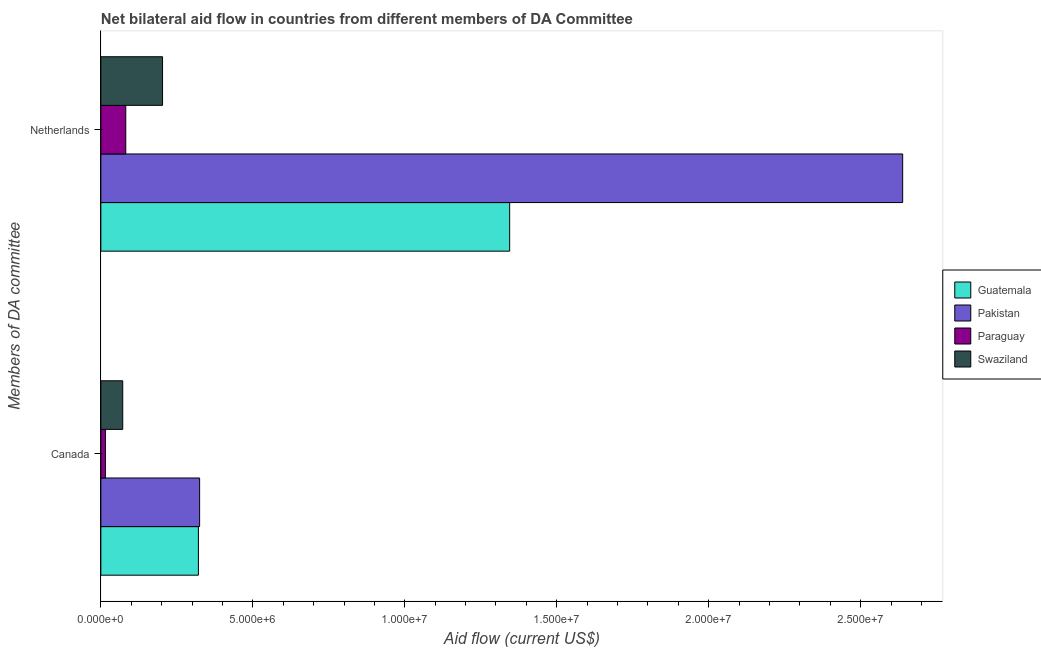How many groups of bars are there?
Provide a short and direct response. 2. Are the number of bars per tick equal to the number of legend labels?
Your answer should be very brief. Yes. Are the number of bars on each tick of the Y-axis equal?
Offer a very short reply. Yes. How many bars are there on the 2nd tick from the top?
Your response must be concise. 4. What is the label of the 2nd group of bars from the top?
Keep it short and to the point. Canada. What is the amount of aid given by canada in Pakistan?
Provide a succinct answer. 3.25e+06. Across all countries, what is the maximum amount of aid given by canada?
Provide a succinct answer. 3.25e+06. Across all countries, what is the minimum amount of aid given by netherlands?
Offer a very short reply. 8.20e+05. In which country was the amount of aid given by canada maximum?
Provide a short and direct response. Pakistan. In which country was the amount of aid given by netherlands minimum?
Keep it short and to the point. Paraguay. What is the total amount of aid given by canada in the graph?
Your response must be concise. 7.33e+06. What is the difference between the amount of aid given by canada in Pakistan and that in Swaziland?
Provide a succinct answer. 2.53e+06. What is the difference between the amount of aid given by netherlands in Pakistan and the amount of aid given by canada in Swaziland?
Provide a short and direct response. 2.57e+07. What is the average amount of aid given by canada per country?
Provide a succinct answer. 1.83e+06. What is the difference between the amount of aid given by canada and amount of aid given by netherlands in Swaziland?
Give a very brief answer. -1.31e+06. What is the ratio of the amount of aid given by netherlands in Pakistan to that in Paraguay?
Offer a terse response. 32.17. What does the 2nd bar from the top in Canada represents?
Your response must be concise. Paraguay. What does the 1st bar from the bottom in Netherlands represents?
Give a very brief answer. Guatemala. How many countries are there in the graph?
Your answer should be compact. 4. What is the difference between two consecutive major ticks on the X-axis?
Your response must be concise. 5.00e+06. Are the values on the major ticks of X-axis written in scientific E-notation?
Offer a very short reply. Yes. Does the graph contain any zero values?
Keep it short and to the point. No. How many legend labels are there?
Give a very brief answer. 4. How are the legend labels stacked?
Offer a terse response. Vertical. What is the title of the graph?
Your answer should be compact. Net bilateral aid flow in countries from different members of DA Committee. What is the label or title of the X-axis?
Your answer should be compact. Aid flow (current US$). What is the label or title of the Y-axis?
Keep it short and to the point. Members of DA committee. What is the Aid flow (current US$) of Guatemala in Canada?
Offer a very short reply. 3.21e+06. What is the Aid flow (current US$) of Pakistan in Canada?
Keep it short and to the point. 3.25e+06. What is the Aid flow (current US$) of Paraguay in Canada?
Offer a very short reply. 1.50e+05. What is the Aid flow (current US$) in Swaziland in Canada?
Give a very brief answer. 7.20e+05. What is the Aid flow (current US$) in Guatemala in Netherlands?
Offer a very short reply. 1.34e+07. What is the Aid flow (current US$) in Pakistan in Netherlands?
Your response must be concise. 2.64e+07. What is the Aid flow (current US$) in Paraguay in Netherlands?
Make the answer very short. 8.20e+05. What is the Aid flow (current US$) of Swaziland in Netherlands?
Offer a very short reply. 2.03e+06. Across all Members of DA committee, what is the maximum Aid flow (current US$) in Guatemala?
Your response must be concise. 1.34e+07. Across all Members of DA committee, what is the maximum Aid flow (current US$) in Pakistan?
Give a very brief answer. 2.64e+07. Across all Members of DA committee, what is the maximum Aid flow (current US$) in Paraguay?
Keep it short and to the point. 8.20e+05. Across all Members of DA committee, what is the maximum Aid flow (current US$) in Swaziland?
Your answer should be very brief. 2.03e+06. Across all Members of DA committee, what is the minimum Aid flow (current US$) in Guatemala?
Keep it short and to the point. 3.21e+06. Across all Members of DA committee, what is the minimum Aid flow (current US$) of Pakistan?
Provide a short and direct response. 3.25e+06. Across all Members of DA committee, what is the minimum Aid flow (current US$) of Paraguay?
Provide a succinct answer. 1.50e+05. Across all Members of DA committee, what is the minimum Aid flow (current US$) in Swaziland?
Provide a short and direct response. 7.20e+05. What is the total Aid flow (current US$) of Guatemala in the graph?
Keep it short and to the point. 1.67e+07. What is the total Aid flow (current US$) of Pakistan in the graph?
Make the answer very short. 2.96e+07. What is the total Aid flow (current US$) in Paraguay in the graph?
Give a very brief answer. 9.70e+05. What is the total Aid flow (current US$) of Swaziland in the graph?
Offer a very short reply. 2.75e+06. What is the difference between the Aid flow (current US$) of Guatemala in Canada and that in Netherlands?
Your answer should be compact. -1.02e+07. What is the difference between the Aid flow (current US$) in Pakistan in Canada and that in Netherlands?
Keep it short and to the point. -2.31e+07. What is the difference between the Aid flow (current US$) of Paraguay in Canada and that in Netherlands?
Provide a short and direct response. -6.70e+05. What is the difference between the Aid flow (current US$) in Swaziland in Canada and that in Netherlands?
Make the answer very short. -1.31e+06. What is the difference between the Aid flow (current US$) of Guatemala in Canada and the Aid flow (current US$) of Pakistan in Netherlands?
Provide a short and direct response. -2.32e+07. What is the difference between the Aid flow (current US$) in Guatemala in Canada and the Aid flow (current US$) in Paraguay in Netherlands?
Give a very brief answer. 2.39e+06. What is the difference between the Aid flow (current US$) in Guatemala in Canada and the Aid flow (current US$) in Swaziland in Netherlands?
Provide a succinct answer. 1.18e+06. What is the difference between the Aid flow (current US$) of Pakistan in Canada and the Aid flow (current US$) of Paraguay in Netherlands?
Provide a short and direct response. 2.43e+06. What is the difference between the Aid flow (current US$) of Pakistan in Canada and the Aid flow (current US$) of Swaziland in Netherlands?
Offer a terse response. 1.22e+06. What is the difference between the Aid flow (current US$) of Paraguay in Canada and the Aid flow (current US$) of Swaziland in Netherlands?
Ensure brevity in your answer.  -1.88e+06. What is the average Aid flow (current US$) of Guatemala per Members of DA committee?
Your answer should be very brief. 8.33e+06. What is the average Aid flow (current US$) of Pakistan per Members of DA committee?
Provide a succinct answer. 1.48e+07. What is the average Aid flow (current US$) of Paraguay per Members of DA committee?
Provide a short and direct response. 4.85e+05. What is the average Aid flow (current US$) in Swaziland per Members of DA committee?
Provide a short and direct response. 1.38e+06. What is the difference between the Aid flow (current US$) in Guatemala and Aid flow (current US$) in Pakistan in Canada?
Keep it short and to the point. -4.00e+04. What is the difference between the Aid flow (current US$) in Guatemala and Aid flow (current US$) in Paraguay in Canada?
Provide a succinct answer. 3.06e+06. What is the difference between the Aid flow (current US$) in Guatemala and Aid flow (current US$) in Swaziland in Canada?
Provide a short and direct response. 2.49e+06. What is the difference between the Aid flow (current US$) in Pakistan and Aid flow (current US$) in Paraguay in Canada?
Make the answer very short. 3.10e+06. What is the difference between the Aid flow (current US$) in Pakistan and Aid flow (current US$) in Swaziland in Canada?
Make the answer very short. 2.53e+06. What is the difference between the Aid flow (current US$) of Paraguay and Aid flow (current US$) of Swaziland in Canada?
Your answer should be very brief. -5.70e+05. What is the difference between the Aid flow (current US$) of Guatemala and Aid flow (current US$) of Pakistan in Netherlands?
Your response must be concise. -1.29e+07. What is the difference between the Aid flow (current US$) in Guatemala and Aid flow (current US$) in Paraguay in Netherlands?
Offer a very short reply. 1.26e+07. What is the difference between the Aid flow (current US$) in Guatemala and Aid flow (current US$) in Swaziland in Netherlands?
Offer a terse response. 1.14e+07. What is the difference between the Aid flow (current US$) in Pakistan and Aid flow (current US$) in Paraguay in Netherlands?
Your answer should be compact. 2.56e+07. What is the difference between the Aid flow (current US$) of Pakistan and Aid flow (current US$) of Swaziland in Netherlands?
Offer a very short reply. 2.44e+07. What is the difference between the Aid flow (current US$) of Paraguay and Aid flow (current US$) of Swaziland in Netherlands?
Give a very brief answer. -1.21e+06. What is the ratio of the Aid flow (current US$) in Guatemala in Canada to that in Netherlands?
Make the answer very short. 0.24. What is the ratio of the Aid flow (current US$) in Pakistan in Canada to that in Netherlands?
Your answer should be compact. 0.12. What is the ratio of the Aid flow (current US$) in Paraguay in Canada to that in Netherlands?
Your answer should be very brief. 0.18. What is the ratio of the Aid flow (current US$) in Swaziland in Canada to that in Netherlands?
Provide a succinct answer. 0.35. What is the difference between the highest and the second highest Aid flow (current US$) in Guatemala?
Ensure brevity in your answer.  1.02e+07. What is the difference between the highest and the second highest Aid flow (current US$) of Pakistan?
Make the answer very short. 2.31e+07. What is the difference between the highest and the second highest Aid flow (current US$) in Paraguay?
Provide a succinct answer. 6.70e+05. What is the difference between the highest and the second highest Aid flow (current US$) in Swaziland?
Give a very brief answer. 1.31e+06. What is the difference between the highest and the lowest Aid flow (current US$) in Guatemala?
Your answer should be very brief. 1.02e+07. What is the difference between the highest and the lowest Aid flow (current US$) in Pakistan?
Your answer should be compact. 2.31e+07. What is the difference between the highest and the lowest Aid flow (current US$) of Paraguay?
Your answer should be compact. 6.70e+05. What is the difference between the highest and the lowest Aid flow (current US$) in Swaziland?
Give a very brief answer. 1.31e+06. 